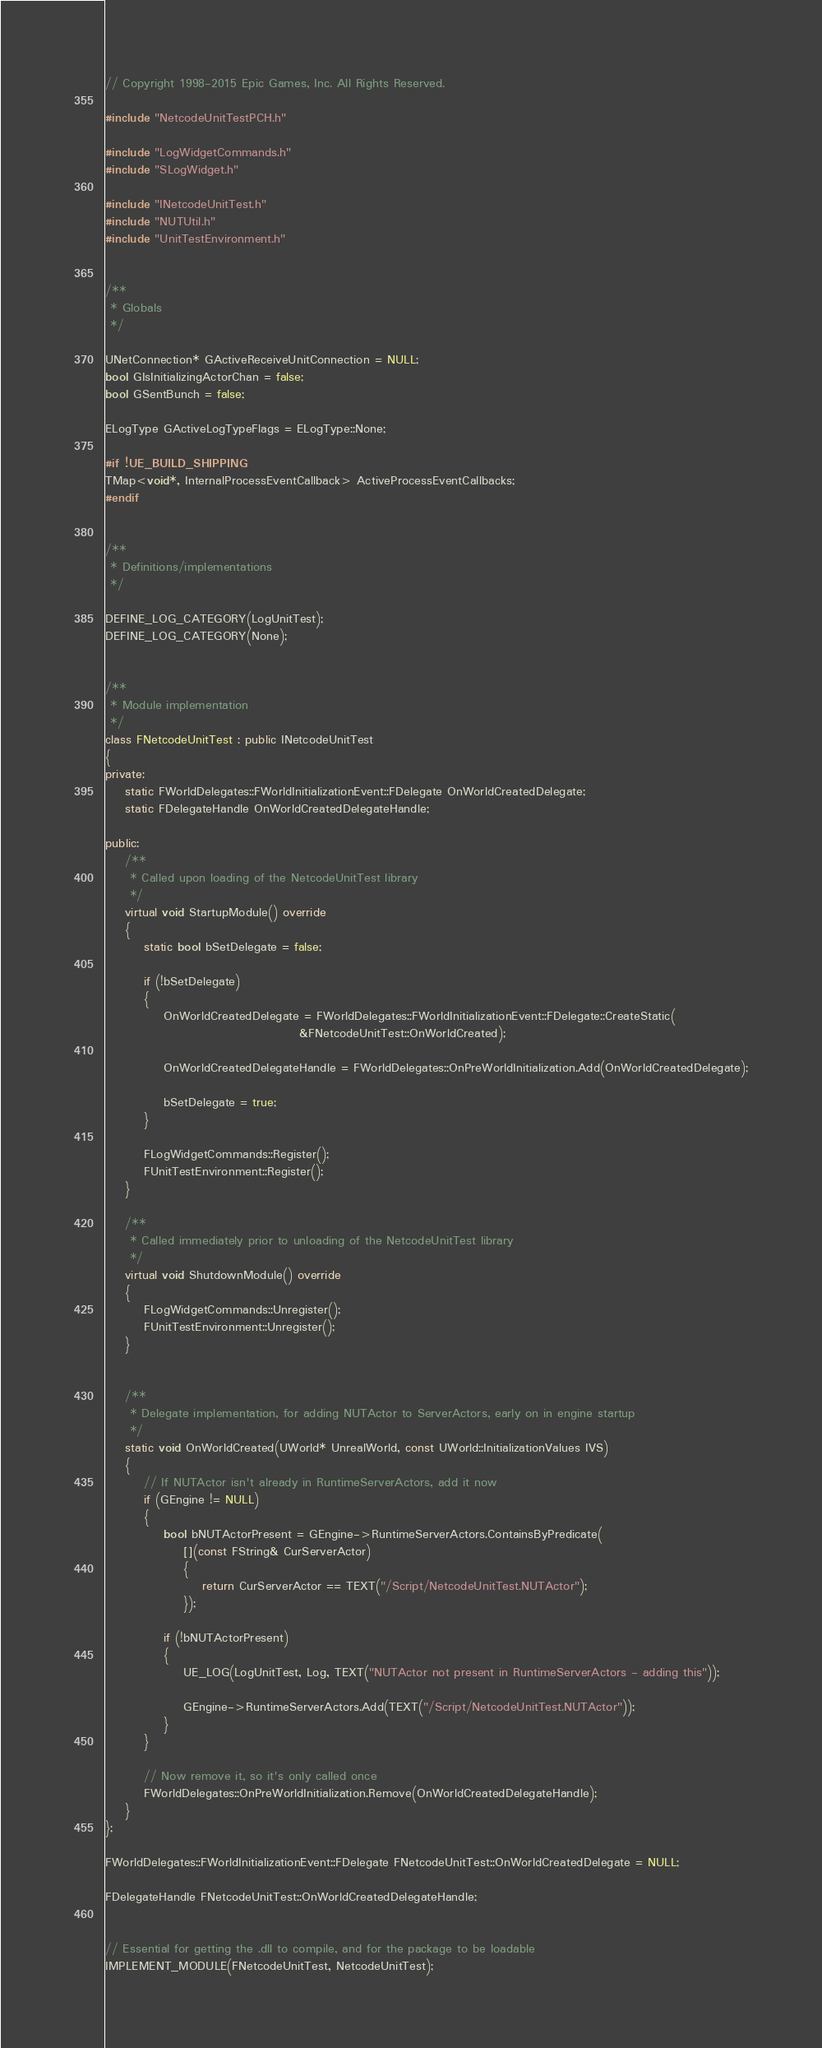<code> <loc_0><loc_0><loc_500><loc_500><_C++_>// Copyright 1998-2015 Epic Games, Inc. All Rights Reserved.

#include "NetcodeUnitTestPCH.h"

#include "LogWidgetCommands.h"
#include "SLogWidget.h"

#include "INetcodeUnitTest.h"
#include "NUTUtil.h"
#include "UnitTestEnvironment.h"


/**
 * Globals
 */

UNetConnection* GActiveReceiveUnitConnection = NULL;
bool GIsInitializingActorChan = false;
bool GSentBunch = false;

ELogType GActiveLogTypeFlags = ELogType::None;

#if !UE_BUILD_SHIPPING
TMap<void*, InternalProcessEventCallback> ActiveProcessEventCallbacks;
#endif


/**
 * Definitions/implementations
 */

DEFINE_LOG_CATEGORY(LogUnitTest);
DEFINE_LOG_CATEGORY(None);


/**
 * Module implementation
 */
class FNetcodeUnitTest : public INetcodeUnitTest
{
private:
	static FWorldDelegates::FWorldInitializationEvent::FDelegate OnWorldCreatedDelegate;
	static FDelegateHandle OnWorldCreatedDelegateHandle;

public:
	/**
	 * Called upon loading of the NetcodeUnitTest library
	 */
	virtual void StartupModule() override
	{
		static bool bSetDelegate = false;

		if (!bSetDelegate)
		{
			OnWorldCreatedDelegate = FWorldDelegates::FWorldInitializationEvent::FDelegate::CreateStatic(
										&FNetcodeUnitTest::OnWorldCreated);

			OnWorldCreatedDelegateHandle = FWorldDelegates::OnPreWorldInitialization.Add(OnWorldCreatedDelegate);

			bSetDelegate = true;
		}

		FLogWidgetCommands::Register();
		FUnitTestEnvironment::Register();
	}

	/**
	 * Called immediately prior to unloading of the NetcodeUnitTest library
	 */
	virtual void ShutdownModule() override
	{
		FLogWidgetCommands::Unregister();
		FUnitTestEnvironment::Unregister();
	}


	/**
	 * Delegate implementation, for adding NUTActor to ServerActors, early on in engine startup
	 */
	static void OnWorldCreated(UWorld* UnrealWorld, const UWorld::InitializationValues IVS)
	{
		// If NUTActor isn't already in RuntimeServerActors, add it now
		if (GEngine != NULL)
		{
			bool bNUTActorPresent = GEngine->RuntimeServerActors.ContainsByPredicate(
				[](const FString& CurServerActor)
				{
					return CurServerActor == TEXT("/Script/NetcodeUnitTest.NUTActor");
				});

			if (!bNUTActorPresent)
			{
				UE_LOG(LogUnitTest, Log, TEXT("NUTActor not present in RuntimeServerActors - adding this"));

				GEngine->RuntimeServerActors.Add(TEXT("/Script/NetcodeUnitTest.NUTActor"));
			}
		}

		// Now remove it, so it's only called once
		FWorldDelegates::OnPreWorldInitialization.Remove(OnWorldCreatedDelegateHandle);
	}
};

FWorldDelegates::FWorldInitializationEvent::FDelegate FNetcodeUnitTest::OnWorldCreatedDelegate = NULL;

FDelegateHandle FNetcodeUnitTest::OnWorldCreatedDelegateHandle;


// Essential for getting the .dll to compile, and for the package to be loadable
IMPLEMENT_MODULE(FNetcodeUnitTest, NetcodeUnitTest);
</code> 